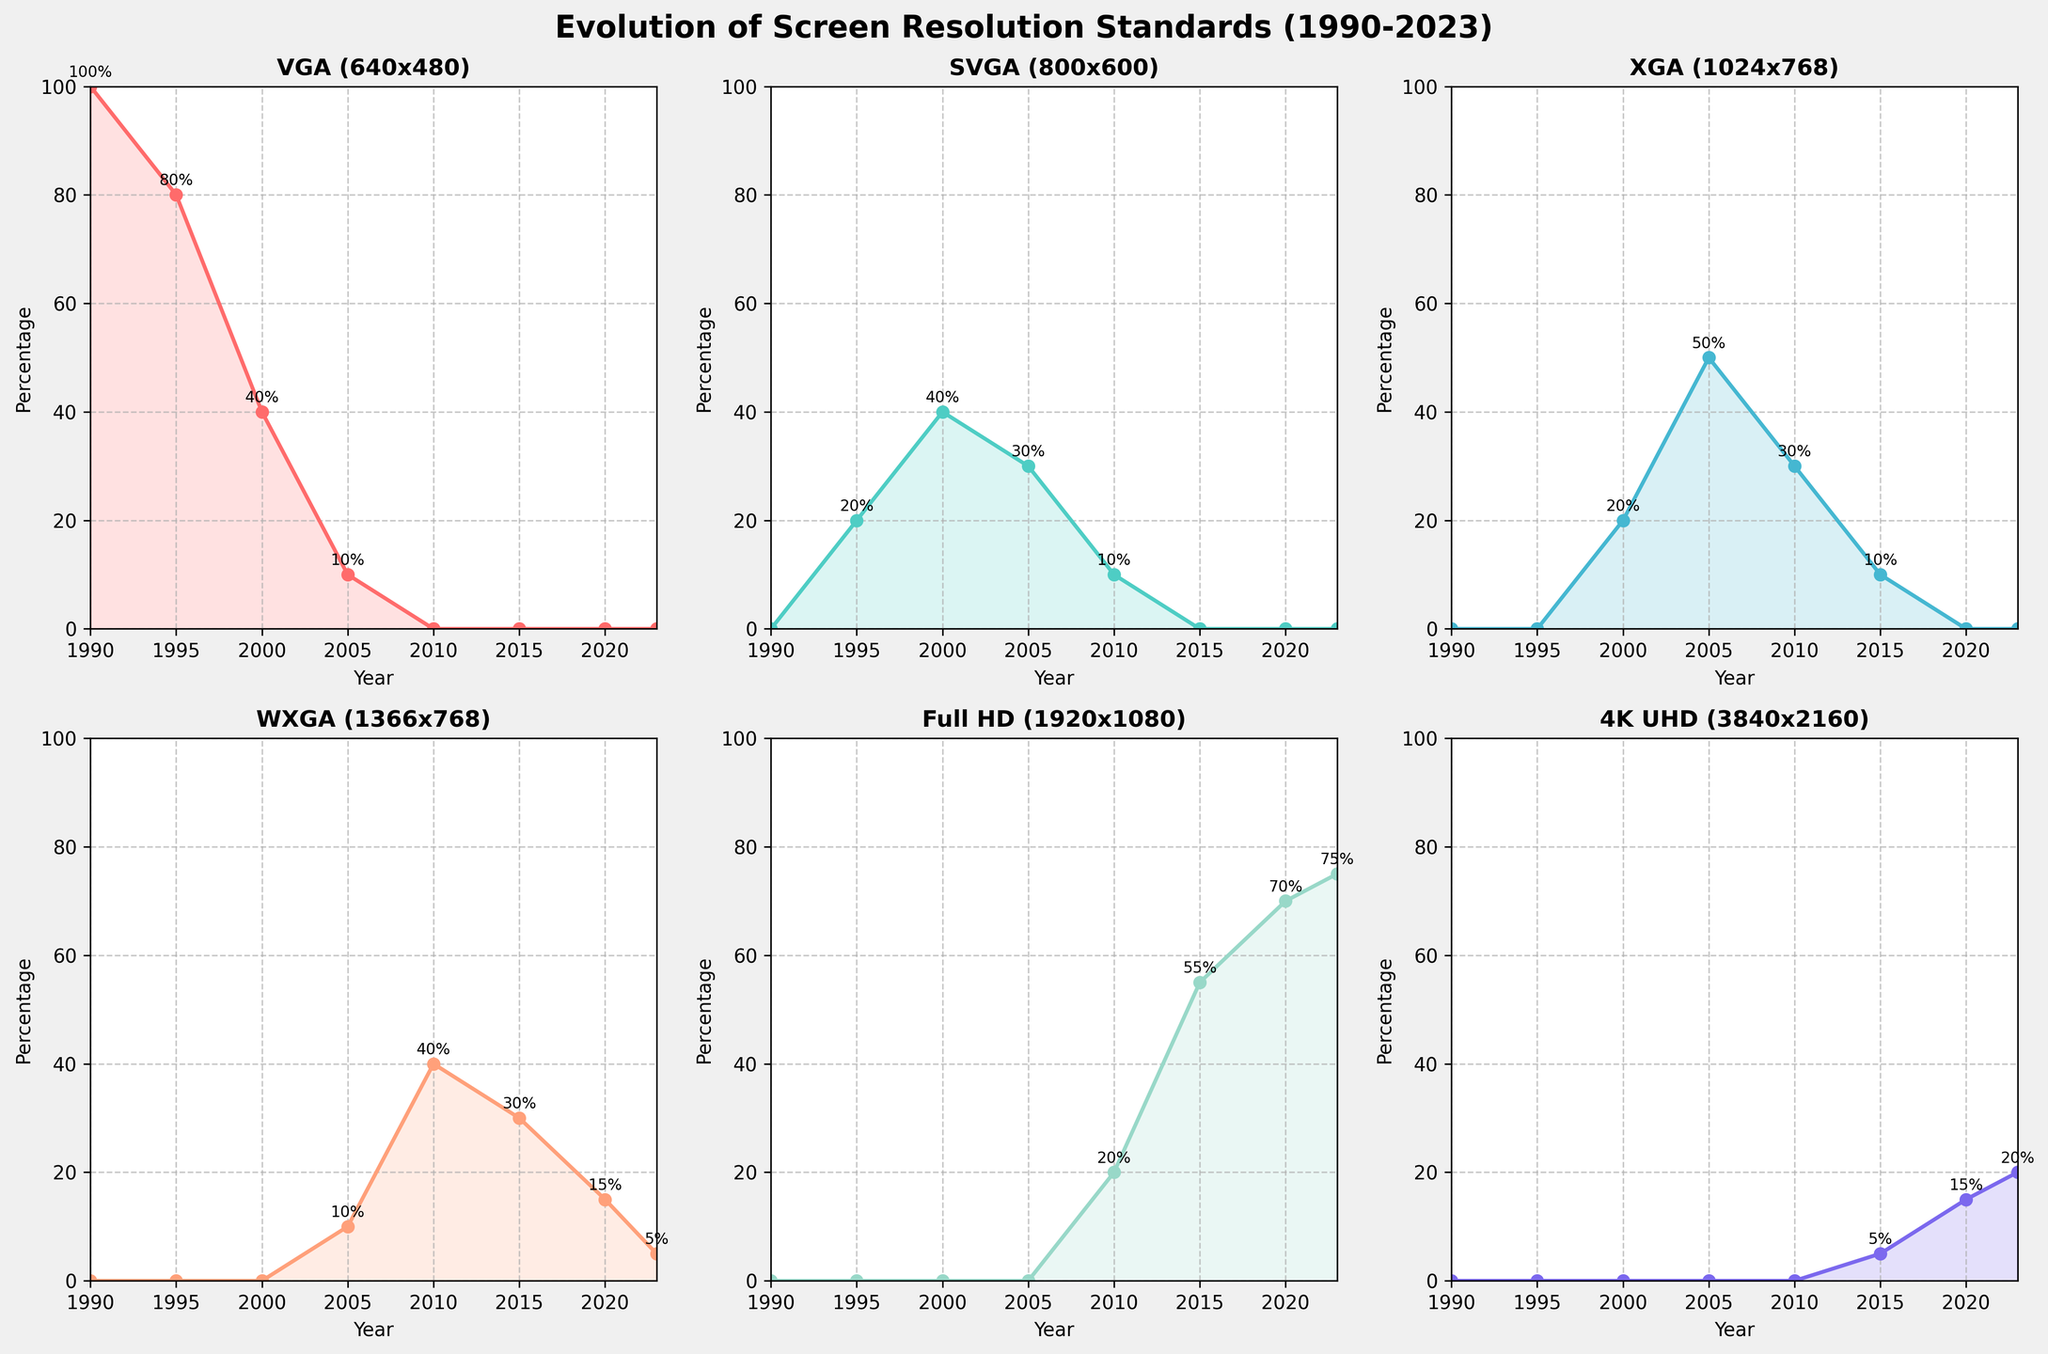When do we first see 4K UHD in the chart? Looking at the subplot for "4K UHD," the data point for the first appearance corresponds to the year 2015.
Answer: 2015 What year did WXGA surpass XGA in percentage share? By examining the subplot for WXGA and XGA, WXGA surpasses XGA between 2005 and 2010; specifically, 2010 is when WXGA at 40% surpassed XGA at 30%.
Answer: 2010 How does the percentage of Full HD change from 2015 to 2023? In the subplot for "Full HD," the values go from 55% in 2015, 70% in 2020, to 75% in 2023, showing an increase over time.
Answer: It increased Which resolution had the highest percentage share in 1990? By looking at all subplots for 1990, VGA had the highest percentage at 100%.
Answer: VGA Which two resolutions had the same percentage in any given year? In 2000, both VGA and SVGA have the same percentage of 40%.
Answer: VGA and SVGA in 2000 What trend do you observe for VGA from 1990 to 2023? By examining the subplot for VGA, the trend indicates a consistent decline from 1990, where it was at 100%, until it disappeared after 2005.
Answer: Declining From 2000 to 2010, how does the introduction of WXGA affect the percentage of XGA? Between 2000 and 2010, XGA's percentage first increases to 50% by 2005 and then decreases to 30% by 2010 as WXGA enters and grows from 10% to 40%.
Answer: Intervention reduces XGA Which resolution has no share after 2005? Referring to the subplots, VGA has no percentage share after 2005.
Answer: VGA Which resolution had the highest increase in percentage share between 2005 and 2015? Checking each subplot, Full HD shows an increase from 0% in 2005 to 55% in 2015, the highest.
Answer: Full HD At what year did Full HD start to dominate the screen resolution standards? The subplot for Full HD shows it starts dominating from 2015 onward, surpassing other resolutions in percentage share.
Answer: 2015 